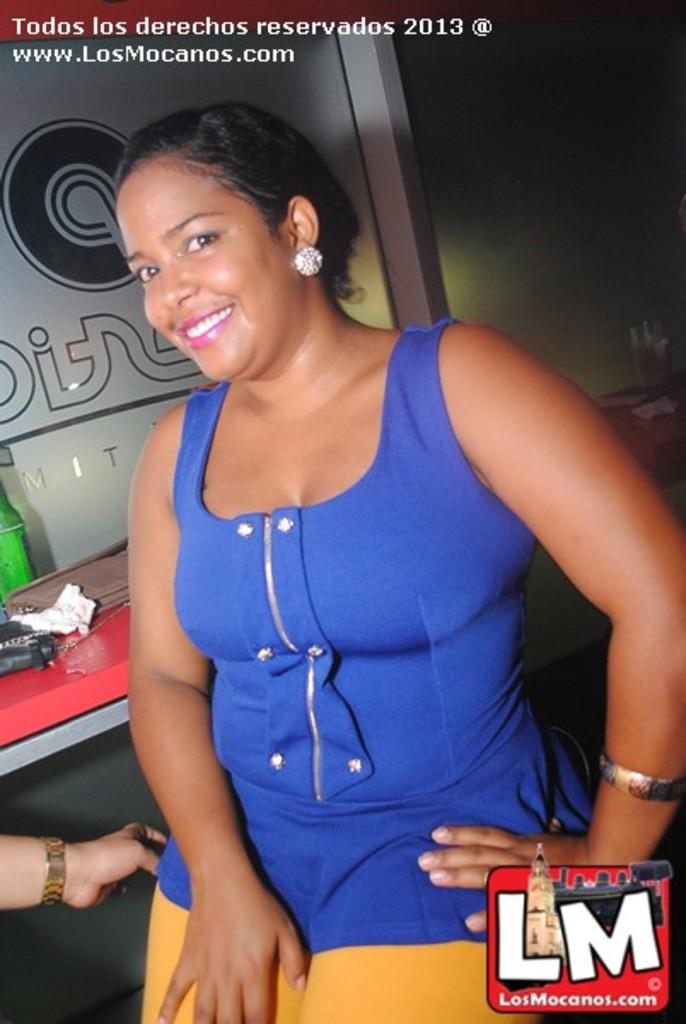What letters make up the logo on the bottom right of the image?
Offer a terse response. Lm. What is the color of her blouse?
Give a very brief answer. Answering does not require reading text in the image. 